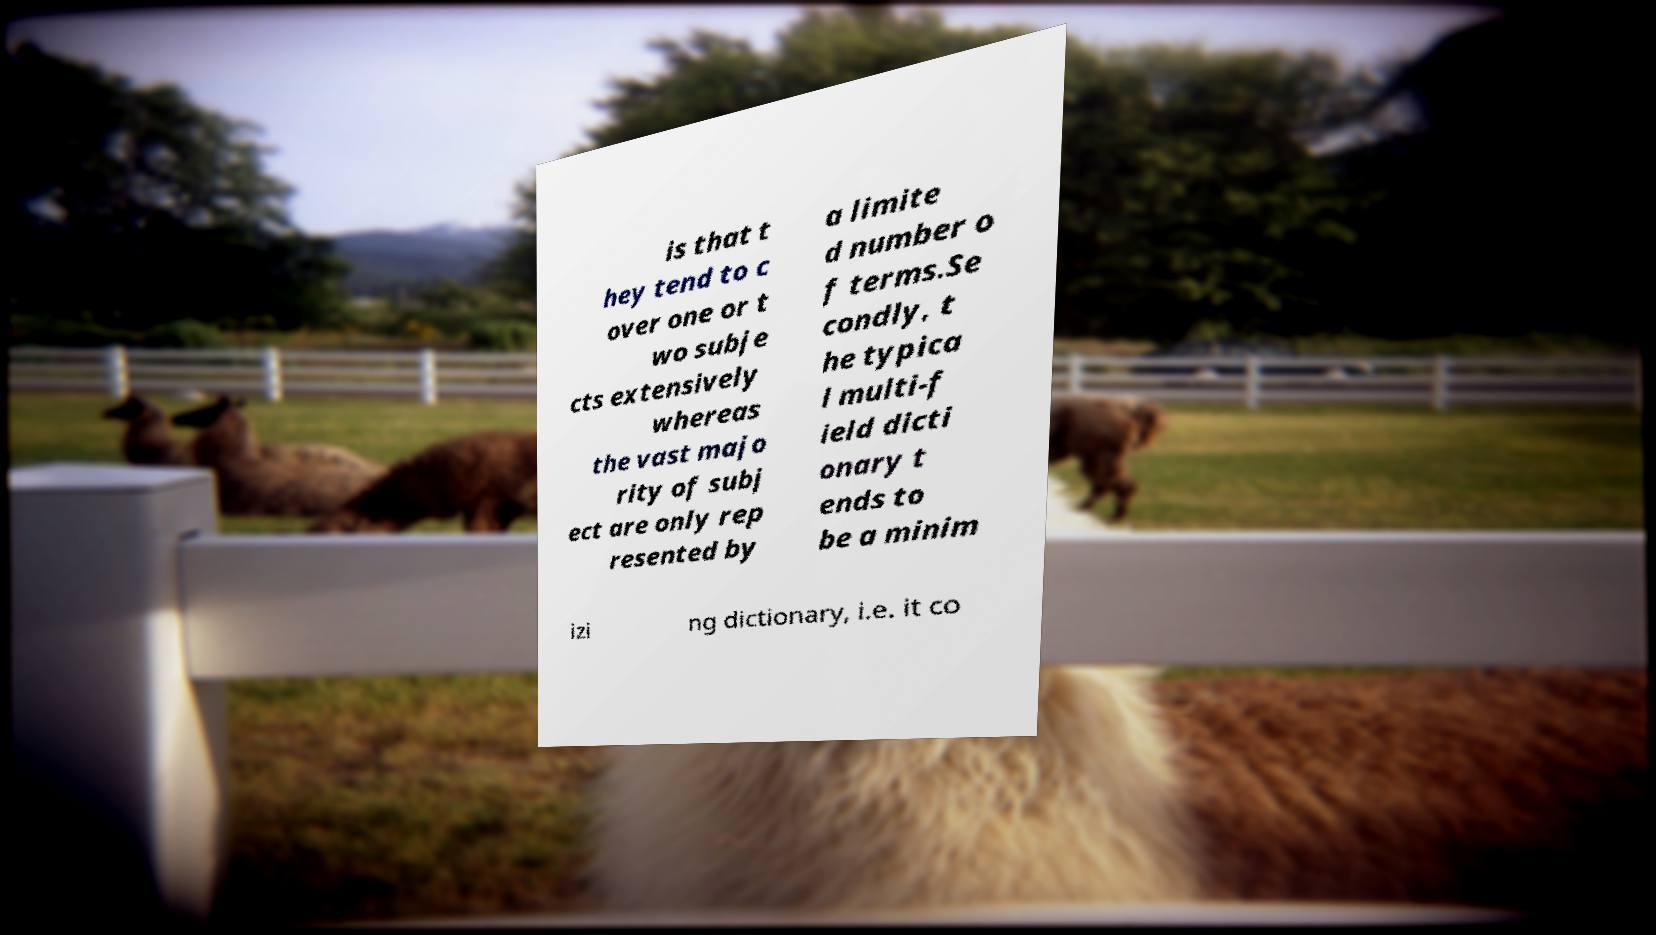Can you read and provide the text displayed in the image?This photo seems to have some interesting text. Can you extract and type it out for me? is that t hey tend to c over one or t wo subje cts extensively whereas the vast majo rity of subj ect are only rep resented by a limite d number o f terms.Se condly, t he typica l multi-f ield dicti onary t ends to be a minim izi ng dictionary, i.e. it co 